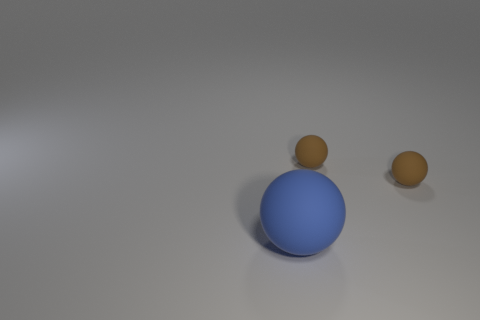What material is the large sphere?
Provide a short and direct response. Rubber. What number of metal objects are balls or small brown things?
Ensure brevity in your answer.  0. The blue sphere is what size?
Provide a short and direct response. Large. How many small matte things are the same shape as the big blue thing?
Ensure brevity in your answer.  2. Are there more brown rubber things right of the big ball than small brown metal cubes?
Give a very brief answer. Yes. How many brown things are the same size as the blue matte sphere?
Offer a terse response. 0. What number of tiny things are blue matte balls or spheres?
Give a very brief answer. 2. What number of blue spheres are there?
Offer a very short reply. 1. Are there any things behind the big sphere?
Your answer should be very brief. Yes. What number of brown things are either matte things or small metallic cylinders?
Make the answer very short. 2. 